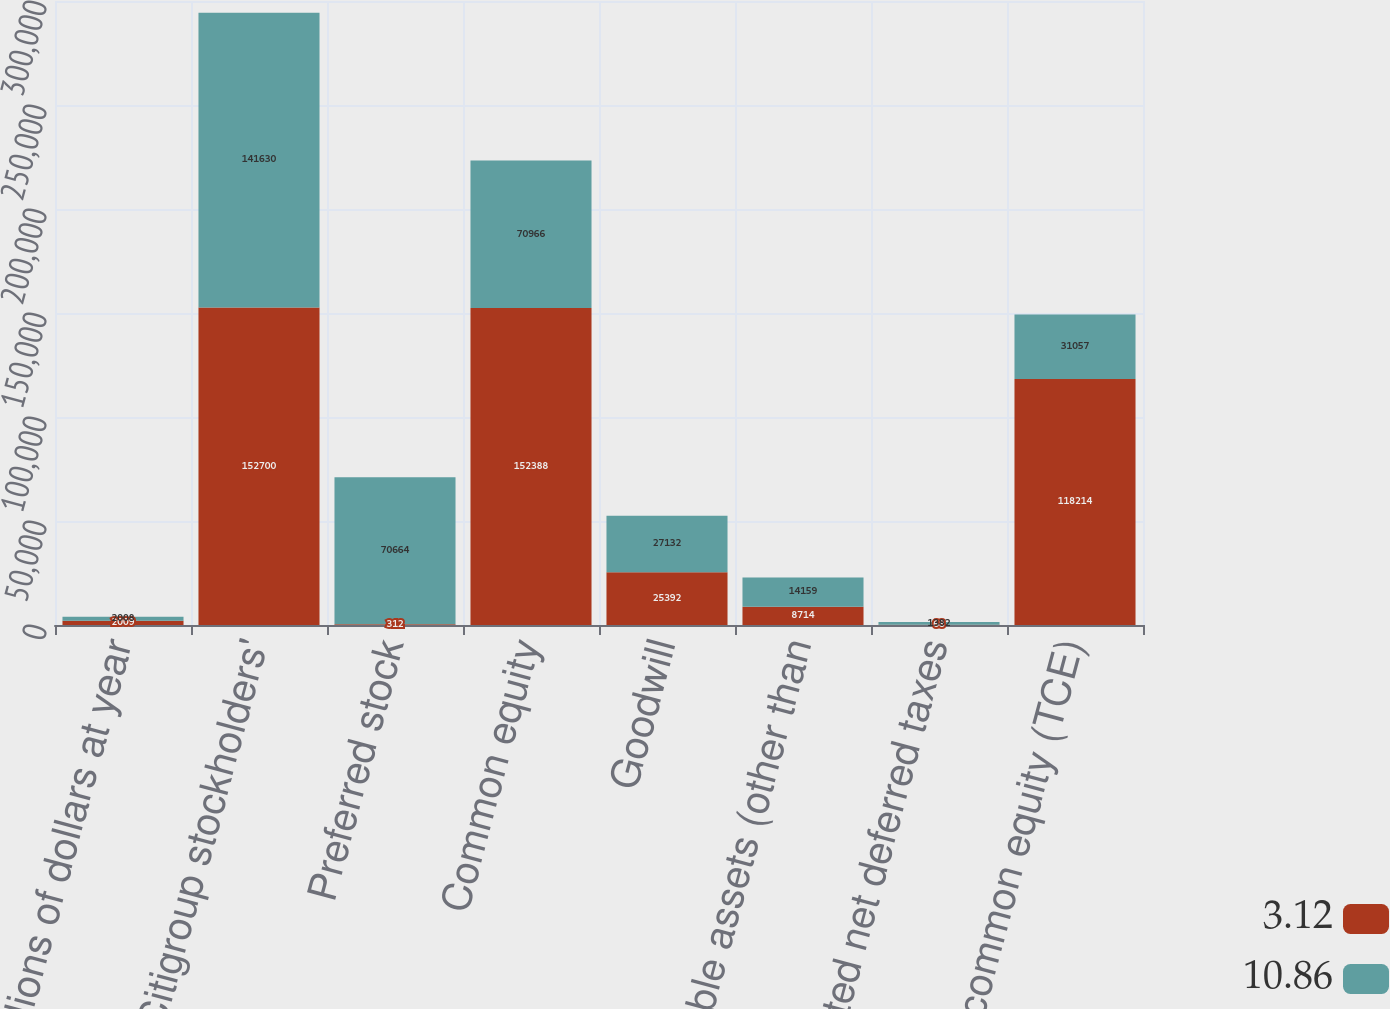<chart> <loc_0><loc_0><loc_500><loc_500><stacked_bar_chart><ecel><fcel>In millions of dollars at year<fcel>Total Citigroup stockholders'<fcel>Preferred stock<fcel>Common equity<fcel>Goodwill<fcel>Intangible assets (other than<fcel>Related net deferred taxes<fcel>Tangible common equity (TCE)<nl><fcel>3.12<fcel>2009<fcel>152700<fcel>312<fcel>152388<fcel>25392<fcel>8714<fcel>68<fcel>118214<nl><fcel>10.86<fcel>2008<fcel>141630<fcel>70664<fcel>70966<fcel>27132<fcel>14159<fcel>1382<fcel>31057<nl></chart> 